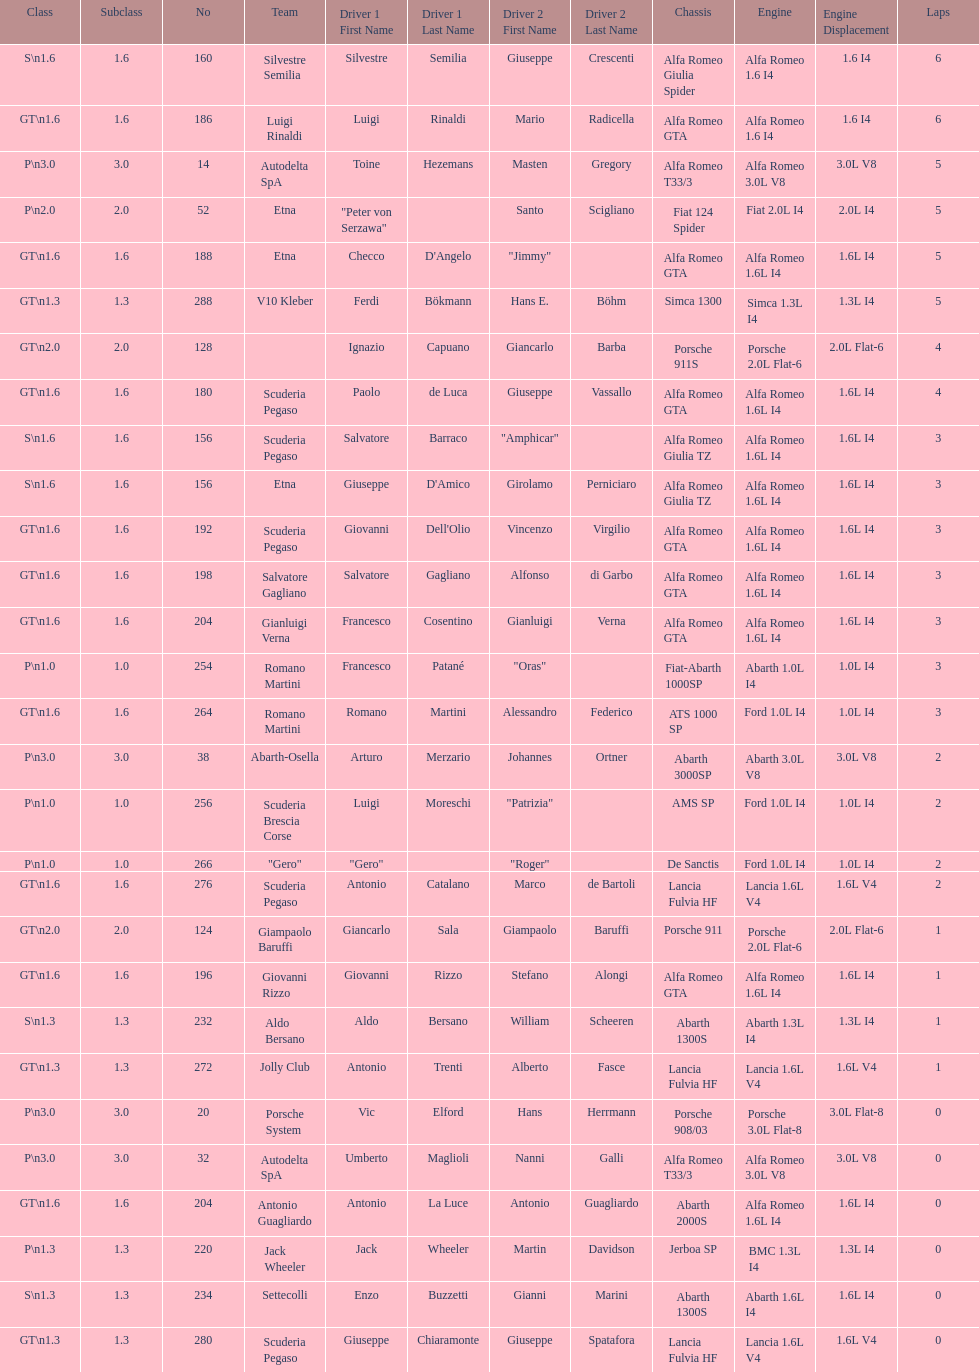Name the only american who did not finish the race. Masten Gregory. 